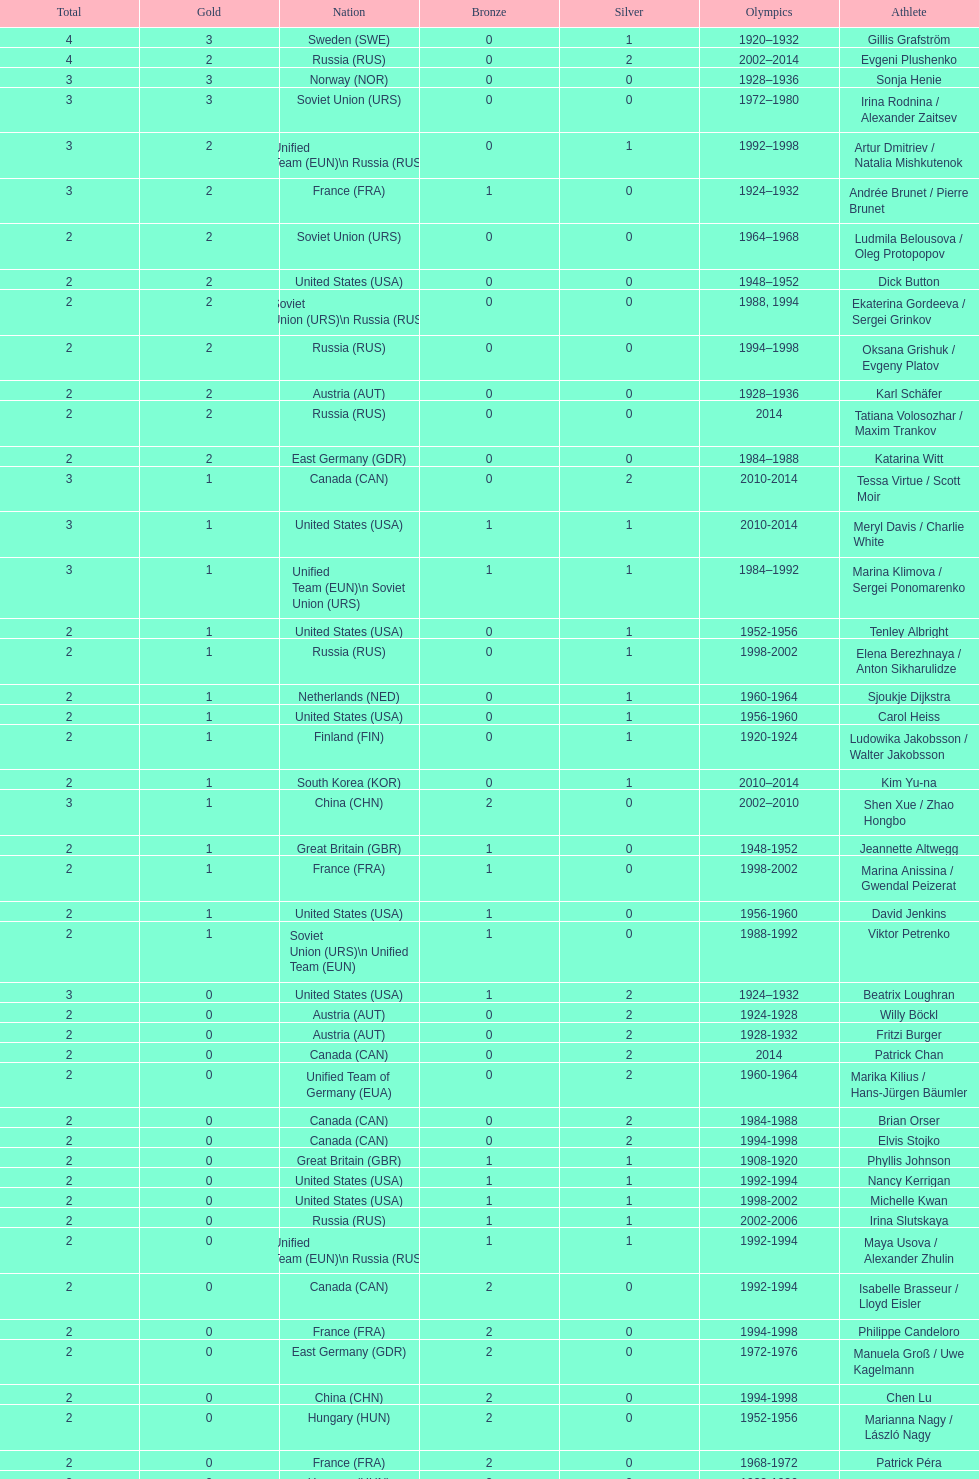How many total medals has the united states won in women's figure skating? 16. 